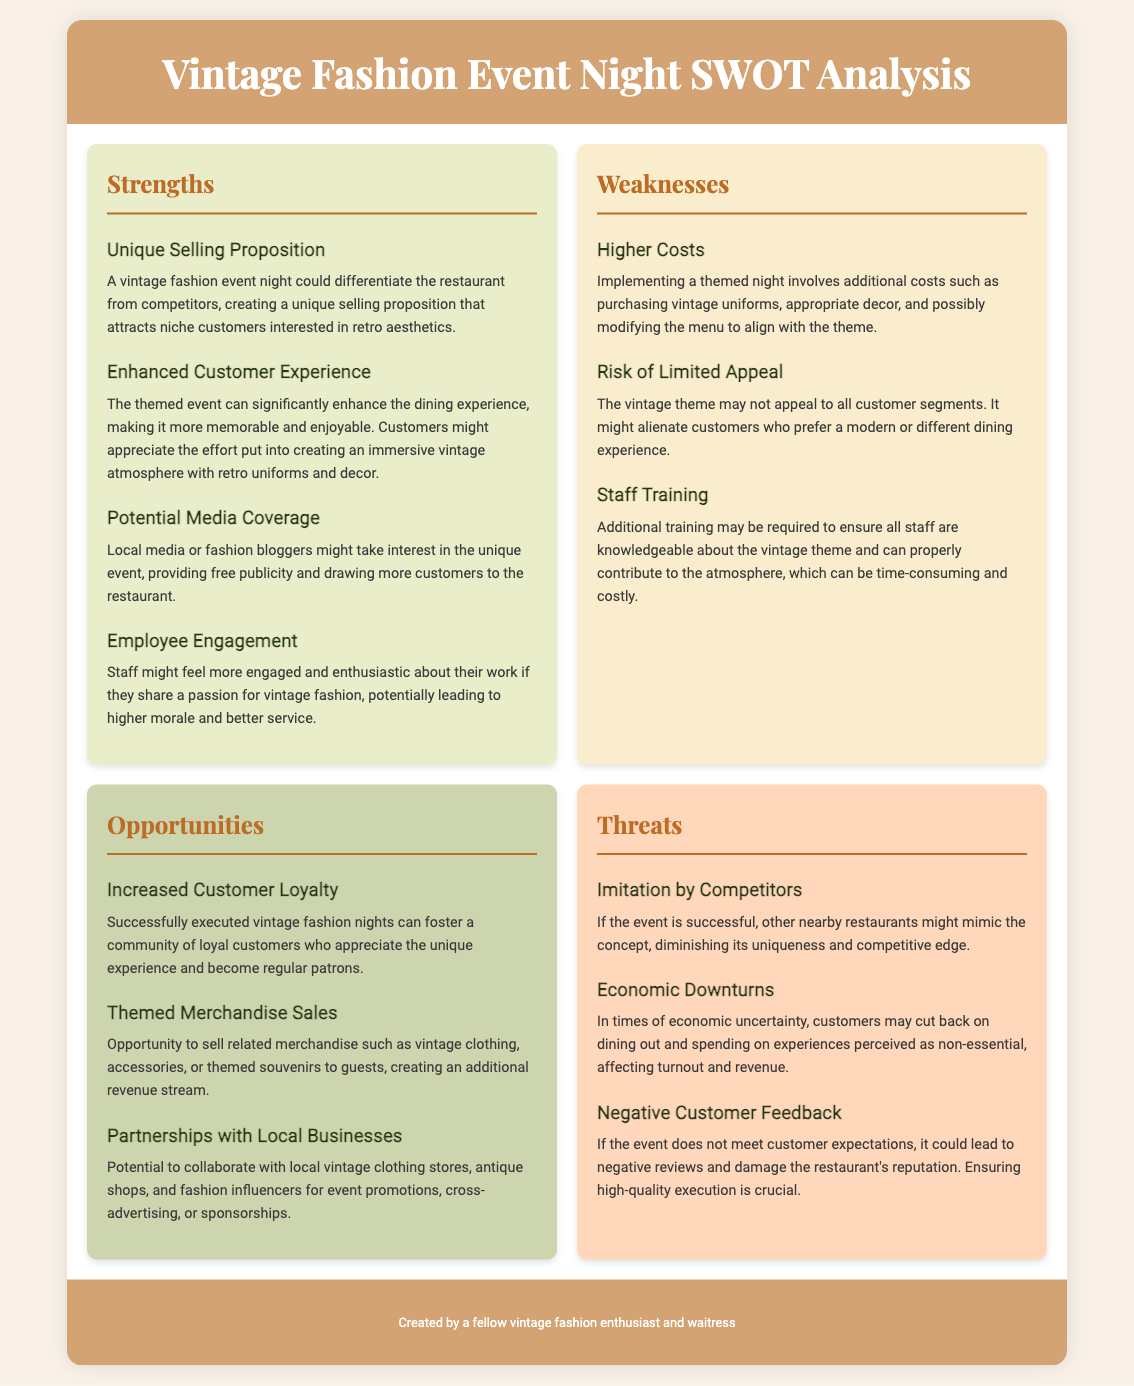What is the unique selling proposition of the vintage fashion event night? This is mentioned in the strengths section, emphasizing how the event could differentiate the restaurant and attract niche customers.
Answer: A vintage fashion event night could differentiate the restaurant from competitors What could enhance customer experience during the event? The enhanced customer experience is highlighted in the strengths section, detailing the immersive atmosphere created by the theme.
Answer: Making it more memorable and enjoyable What is a potential opportunity related to customer loyalty? This opportunity involves building a community that appreciates the event, stated in the opportunities section.
Answer: Fostering a community of loyal customers What costs are associated with the implementation of the vintage fashion event night? Higher costs are listed under weaknesses, signaling potential financial implications.
Answer: Additional costs such as purchasing vintage uniforms Which threat relates to the actions of competitors? This refers to the competitive landscape described in the threats section, indicating potential imitation.
Answer: Imitation by competitors What is a suggested way to collaborate with local businesses? This opportunity discusses potential partnerships that can enhance event promotions, found in the opportunities section.
Answer: Collaborate with local vintage clothing stores How might economic conditions affect the event? This relates to how external factors can influence customer behavior, noted in the threats section.
Answer: Customers may cut back on dining out What staff-related challenge is mentioned in the weaknesses section? It concerns the need for additional training related to the event theme, highlighting a potential operational hurdle.
Answer: Staff training 